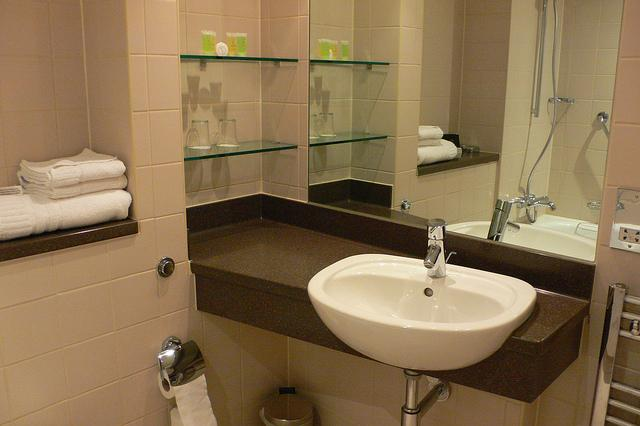What happens if you pull the lever in the middle of the photo? Please explain your reasoning. water comes. The water will come. 